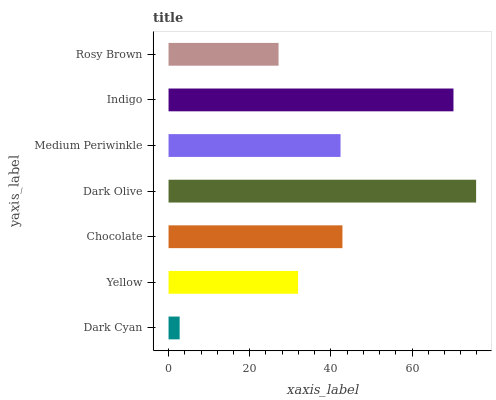Is Dark Cyan the minimum?
Answer yes or no. Yes. Is Dark Olive the maximum?
Answer yes or no. Yes. Is Yellow the minimum?
Answer yes or no. No. Is Yellow the maximum?
Answer yes or no. No. Is Yellow greater than Dark Cyan?
Answer yes or no. Yes. Is Dark Cyan less than Yellow?
Answer yes or no. Yes. Is Dark Cyan greater than Yellow?
Answer yes or no. No. Is Yellow less than Dark Cyan?
Answer yes or no. No. Is Medium Periwinkle the high median?
Answer yes or no. Yes. Is Medium Periwinkle the low median?
Answer yes or no. Yes. Is Chocolate the high median?
Answer yes or no. No. Is Dark Olive the low median?
Answer yes or no. No. 